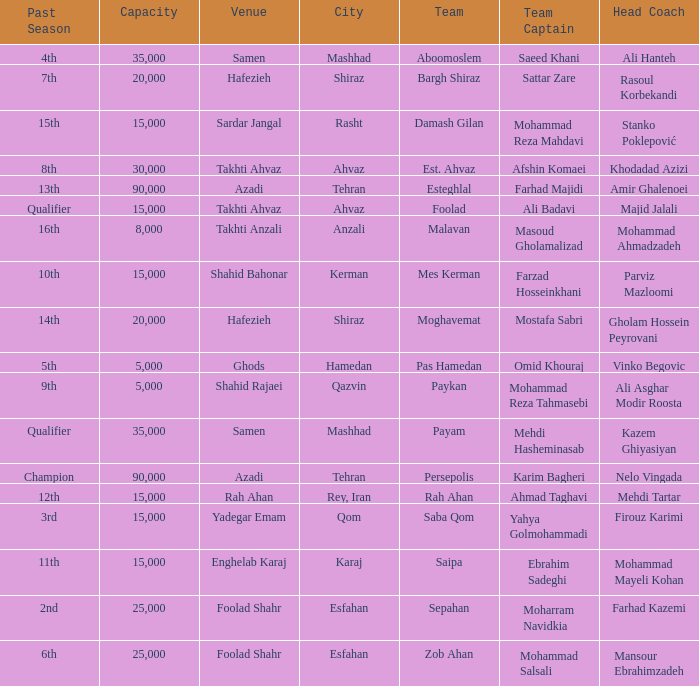What is the Capacity of the Venue of Head Coach Farhad Kazemi? 25000.0. 